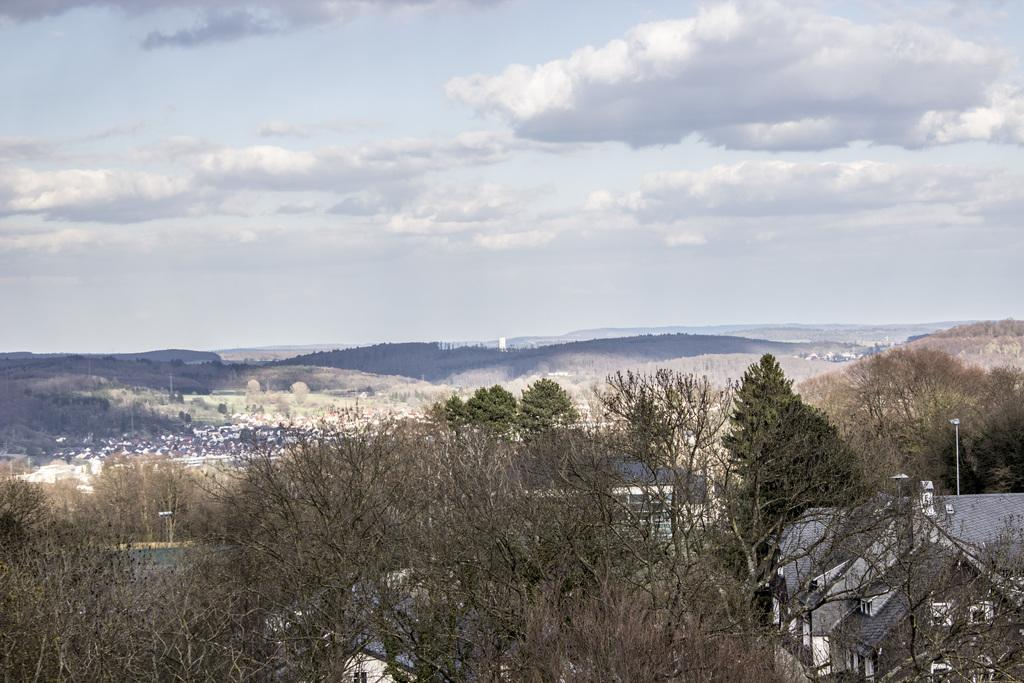What type of natural vegetation is visible in the image? There are trees in the image. What type of man-made structures can be seen in the image? There are houses in the image. What type of geographical feature is visible in the image? There are hills in the image. What is visible in the sky in the image? The sky is visible in the image, and there are clouds in the sky. What type of destruction can be seen happening to the trees in the image? There is no destruction visible in the image; the trees appear intact. What type of tool is being used to cut the doll in the image? There is no doll present in the image, and therefore no tool is being used to cut it. 